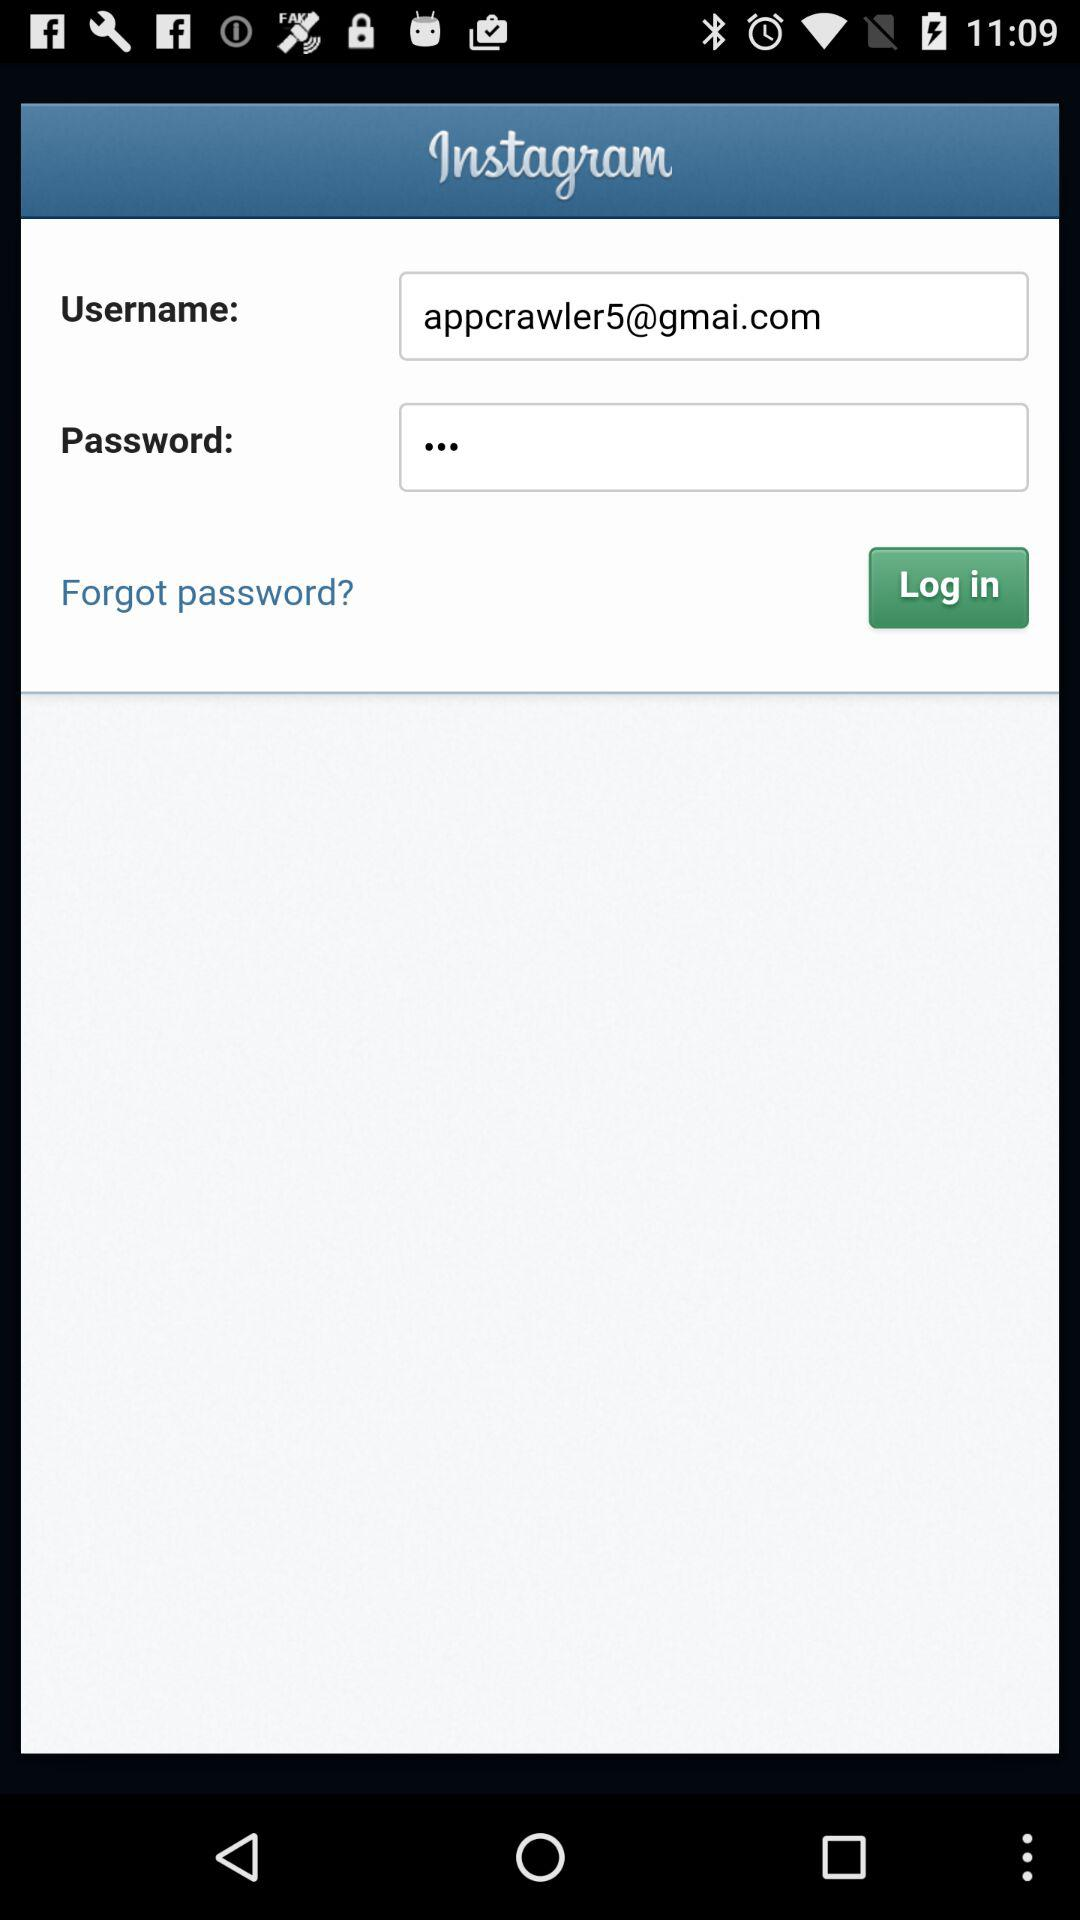How many characters are required to create a password?
When the provided information is insufficient, respond with <no answer>. <no answer> 